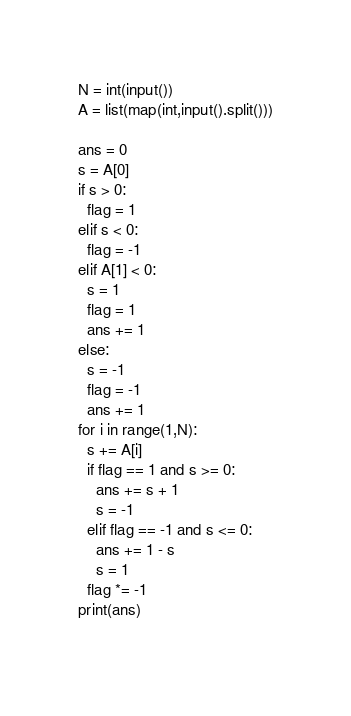<code> <loc_0><loc_0><loc_500><loc_500><_Python_>N = int(input())
A = list(map(int,input().split()))

ans = 0
s = A[0]
if s > 0:
  flag = 1
elif s < 0:
  flag = -1
elif A[1] < 0:
  s = 1
  flag = 1
  ans += 1
else:
  s = -1
  flag = -1
  ans += 1
for i in range(1,N):
  s += A[i]
  if flag == 1 and s >= 0:
    ans += s + 1
    s = -1
  elif flag == -1 and s <= 0:
    ans += 1 - s
    s = 1
  flag *= -1
print(ans)
  </code> 